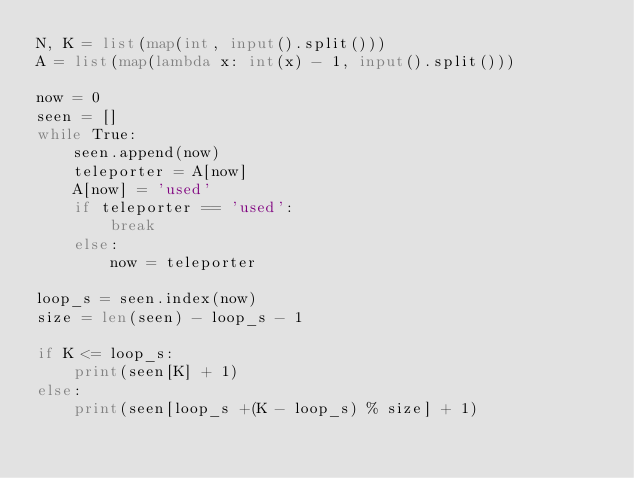<code> <loc_0><loc_0><loc_500><loc_500><_Python_>N, K = list(map(int, input().split()))
A = list(map(lambda x: int(x) - 1, input().split()))

now = 0
seen = []
while True:
    seen.append(now)
    teleporter = A[now]
    A[now] = 'used'
    if teleporter == 'used':
        break
    else:
        now = teleporter  

loop_s = seen.index(now)
size = len(seen) - loop_s - 1

if K <= loop_s:
    print(seen[K] + 1)
else:
    print(seen[loop_s +(K - loop_s) % size] + 1)</code> 